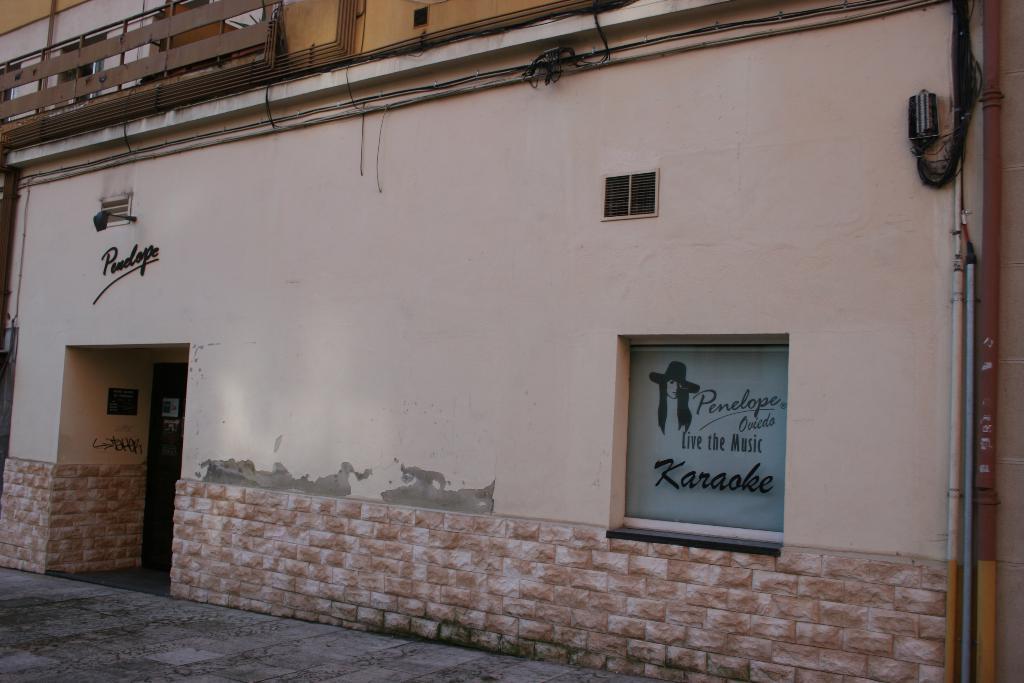Could you give a brief overview of what you see in this image? This image is taken outdoors. At the bottom of the image there is a floor. In the middle of the image there is a building with a wall, windows and a door. There are a few pipe lines and there are a few iron bars. 